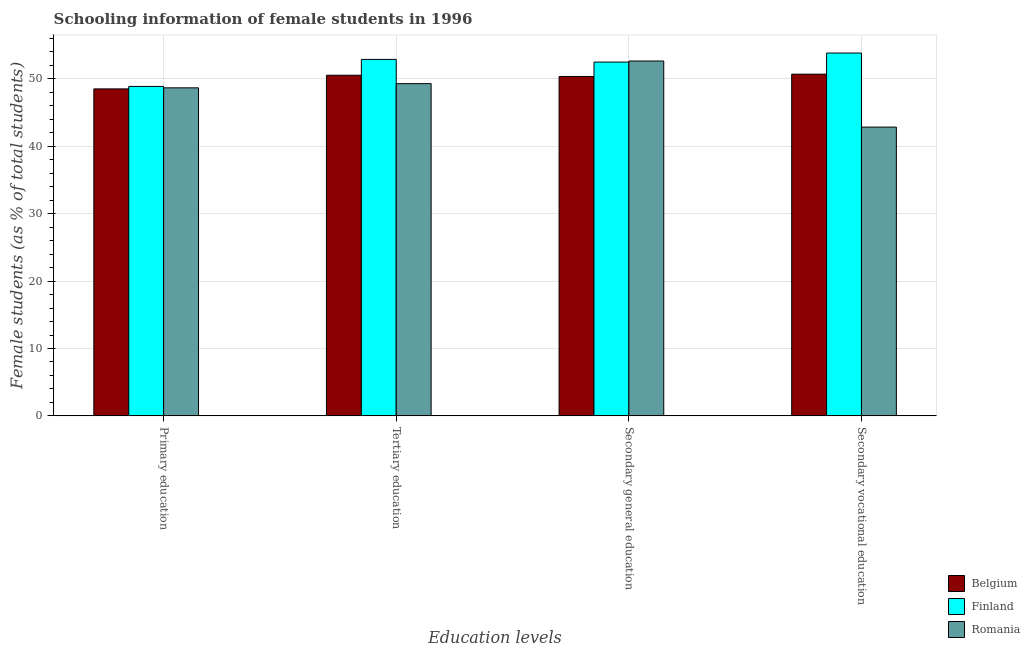How many different coloured bars are there?
Make the answer very short. 3. How many groups of bars are there?
Provide a short and direct response. 4. Are the number of bars on each tick of the X-axis equal?
Ensure brevity in your answer.  Yes. How many bars are there on the 4th tick from the left?
Your answer should be compact. 3. What is the label of the 2nd group of bars from the left?
Provide a succinct answer. Tertiary education. What is the percentage of female students in primary education in Belgium?
Offer a very short reply. 48.52. Across all countries, what is the maximum percentage of female students in secondary education?
Your response must be concise. 52.66. Across all countries, what is the minimum percentage of female students in tertiary education?
Ensure brevity in your answer.  49.3. In which country was the percentage of female students in secondary vocational education minimum?
Provide a succinct answer. Romania. What is the total percentage of female students in primary education in the graph?
Keep it short and to the point. 146.09. What is the difference between the percentage of female students in tertiary education in Finland and that in Romania?
Ensure brevity in your answer.  3.6. What is the difference between the percentage of female students in primary education in Finland and the percentage of female students in tertiary education in Belgium?
Provide a succinct answer. -1.66. What is the average percentage of female students in tertiary education per country?
Provide a succinct answer. 50.92. What is the difference between the percentage of female students in primary education and percentage of female students in tertiary education in Romania?
Your response must be concise. -0.62. What is the ratio of the percentage of female students in secondary education in Belgium to that in Romania?
Your answer should be compact. 0.96. Is the difference between the percentage of female students in tertiary education in Belgium and Finland greater than the difference between the percentage of female students in secondary vocational education in Belgium and Finland?
Your answer should be compact. Yes. What is the difference between the highest and the second highest percentage of female students in secondary vocational education?
Keep it short and to the point. 3.14. What is the difference between the highest and the lowest percentage of female students in secondary education?
Your answer should be very brief. 2.29. What does the 3rd bar from the left in Secondary vocational education represents?
Offer a very short reply. Romania. What does the 1st bar from the right in Secondary vocational education represents?
Provide a succinct answer. Romania. Is it the case that in every country, the sum of the percentage of female students in primary education and percentage of female students in tertiary education is greater than the percentage of female students in secondary education?
Give a very brief answer. Yes. How many bars are there?
Provide a short and direct response. 12. Are all the bars in the graph horizontal?
Make the answer very short. No. Are the values on the major ticks of Y-axis written in scientific E-notation?
Your answer should be very brief. No. Does the graph contain grids?
Your answer should be very brief. Yes. What is the title of the graph?
Give a very brief answer. Schooling information of female students in 1996. Does "Middle East & North Africa (all income levels)" appear as one of the legend labels in the graph?
Provide a succinct answer. No. What is the label or title of the X-axis?
Your answer should be very brief. Education levels. What is the label or title of the Y-axis?
Make the answer very short. Female students (as % of total students). What is the Female students (as % of total students) in Belgium in Primary education?
Provide a succinct answer. 48.52. What is the Female students (as % of total students) of Finland in Primary education?
Provide a succinct answer. 48.89. What is the Female students (as % of total students) in Romania in Primary education?
Give a very brief answer. 48.68. What is the Female students (as % of total students) of Belgium in Tertiary education?
Provide a succinct answer. 50.55. What is the Female students (as % of total students) in Finland in Tertiary education?
Ensure brevity in your answer.  52.9. What is the Female students (as % of total students) in Romania in Tertiary education?
Ensure brevity in your answer.  49.3. What is the Female students (as % of total students) of Belgium in Secondary general education?
Provide a succinct answer. 50.37. What is the Female students (as % of total students) of Finland in Secondary general education?
Ensure brevity in your answer.  52.5. What is the Female students (as % of total students) of Romania in Secondary general education?
Make the answer very short. 52.66. What is the Female students (as % of total students) in Belgium in Secondary vocational education?
Give a very brief answer. 50.71. What is the Female students (as % of total students) of Finland in Secondary vocational education?
Your answer should be compact. 53.85. What is the Female students (as % of total students) in Romania in Secondary vocational education?
Provide a succinct answer. 42.85. Across all Education levels, what is the maximum Female students (as % of total students) of Belgium?
Offer a terse response. 50.71. Across all Education levels, what is the maximum Female students (as % of total students) in Finland?
Offer a very short reply. 53.85. Across all Education levels, what is the maximum Female students (as % of total students) in Romania?
Your answer should be compact. 52.66. Across all Education levels, what is the minimum Female students (as % of total students) of Belgium?
Your answer should be very brief. 48.52. Across all Education levels, what is the minimum Female students (as % of total students) of Finland?
Your answer should be compact. 48.89. Across all Education levels, what is the minimum Female students (as % of total students) in Romania?
Your response must be concise. 42.85. What is the total Female students (as % of total students) of Belgium in the graph?
Your response must be concise. 200.15. What is the total Female students (as % of total students) of Finland in the graph?
Give a very brief answer. 208.14. What is the total Female students (as % of total students) in Romania in the graph?
Your answer should be very brief. 193.49. What is the difference between the Female students (as % of total students) of Belgium in Primary education and that in Tertiary education?
Offer a very short reply. -2.03. What is the difference between the Female students (as % of total students) in Finland in Primary education and that in Tertiary education?
Make the answer very short. -4.01. What is the difference between the Female students (as % of total students) in Romania in Primary education and that in Tertiary education?
Offer a very short reply. -0.62. What is the difference between the Female students (as % of total students) of Belgium in Primary education and that in Secondary general education?
Give a very brief answer. -1.84. What is the difference between the Female students (as % of total students) in Finland in Primary education and that in Secondary general education?
Offer a very short reply. -3.61. What is the difference between the Female students (as % of total students) in Romania in Primary education and that in Secondary general education?
Offer a very short reply. -3.98. What is the difference between the Female students (as % of total students) of Belgium in Primary education and that in Secondary vocational education?
Make the answer very short. -2.19. What is the difference between the Female students (as % of total students) in Finland in Primary education and that in Secondary vocational education?
Give a very brief answer. -4.96. What is the difference between the Female students (as % of total students) in Romania in Primary education and that in Secondary vocational education?
Provide a succinct answer. 5.83. What is the difference between the Female students (as % of total students) in Belgium in Tertiary education and that in Secondary general education?
Offer a very short reply. 0.18. What is the difference between the Female students (as % of total students) in Finland in Tertiary education and that in Secondary general education?
Your response must be concise. 0.39. What is the difference between the Female students (as % of total students) of Romania in Tertiary education and that in Secondary general education?
Your answer should be very brief. -3.36. What is the difference between the Female students (as % of total students) in Belgium in Tertiary education and that in Secondary vocational education?
Ensure brevity in your answer.  -0.16. What is the difference between the Female students (as % of total students) of Finland in Tertiary education and that in Secondary vocational education?
Keep it short and to the point. -0.95. What is the difference between the Female students (as % of total students) of Romania in Tertiary education and that in Secondary vocational education?
Make the answer very short. 6.45. What is the difference between the Female students (as % of total students) of Belgium in Secondary general education and that in Secondary vocational education?
Provide a succinct answer. -0.34. What is the difference between the Female students (as % of total students) of Finland in Secondary general education and that in Secondary vocational education?
Provide a short and direct response. -1.34. What is the difference between the Female students (as % of total students) of Romania in Secondary general education and that in Secondary vocational education?
Make the answer very short. 9.81. What is the difference between the Female students (as % of total students) of Belgium in Primary education and the Female students (as % of total students) of Finland in Tertiary education?
Keep it short and to the point. -4.37. What is the difference between the Female students (as % of total students) in Belgium in Primary education and the Female students (as % of total students) in Romania in Tertiary education?
Give a very brief answer. -0.78. What is the difference between the Female students (as % of total students) of Finland in Primary education and the Female students (as % of total students) of Romania in Tertiary education?
Provide a short and direct response. -0.41. What is the difference between the Female students (as % of total students) in Belgium in Primary education and the Female students (as % of total students) in Finland in Secondary general education?
Offer a terse response. -3.98. What is the difference between the Female students (as % of total students) in Belgium in Primary education and the Female students (as % of total students) in Romania in Secondary general education?
Provide a succinct answer. -4.14. What is the difference between the Female students (as % of total students) in Finland in Primary education and the Female students (as % of total students) in Romania in Secondary general education?
Your answer should be compact. -3.77. What is the difference between the Female students (as % of total students) of Belgium in Primary education and the Female students (as % of total students) of Finland in Secondary vocational education?
Your answer should be very brief. -5.32. What is the difference between the Female students (as % of total students) of Belgium in Primary education and the Female students (as % of total students) of Romania in Secondary vocational education?
Keep it short and to the point. 5.67. What is the difference between the Female students (as % of total students) of Finland in Primary education and the Female students (as % of total students) of Romania in Secondary vocational education?
Your answer should be compact. 6.04. What is the difference between the Female students (as % of total students) in Belgium in Tertiary education and the Female students (as % of total students) in Finland in Secondary general education?
Offer a terse response. -1.95. What is the difference between the Female students (as % of total students) of Belgium in Tertiary education and the Female students (as % of total students) of Romania in Secondary general education?
Make the answer very short. -2.11. What is the difference between the Female students (as % of total students) of Finland in Tertiary education and the Female students (as % of total students) of Romania in Secondary general education?
Your response must be concise. 0.24. What is the difference between the Female students (as % of total students) of Belgium in Tertiary education and the Female students (as % of total students) of Finland in Secondary vocational education?
Offer a terse response. -3.3. What is the difference between the Female students (as % of total students) in Belgium in Tertiary education and the Female students (as % of total students) in Romania in Secondary vocational education?
Your answer should be compact. 7.7. What is the difference between the Female students (as % of total students) in Finland in Tertiary education and the Female students (as % of total students) in Romania in Secondary vocational education?
Ensure brevity in your answer.  10.04. What is the difference between the Female students (as % of total students) of Belgium in Secondary general education and the Female students (as % of total students) of Finland in Secondary vocational education?
Offer a terse response. -3.48. What is the difference between the Female students (as % of total students) of Belgium in Secondary general education and the Female students (as % of total students) of Romania in Secondary vocational education?
Your answer should be compact. 7.51. What is the difference between the Female students (as % of total students) in Finland in Secondary general education and the Female students (as % of total students) in Romania in Secondary vocational education?
Offer a very short reply. 9.65. What is the average Female students (as % of total students) of Belgium per Education levels?
Your answer should be very brief. 50.04. What is the average Female students (as % of total students) in Finland per Education levels?
Make the answer very short. 52.03. What is the average Female students (as % of total students) in Romania per Education levels?
Offer a very short reply. 48.37. What is the difference between the Female students (as % of total students) in Belgium and Female students (as % of total students) in Finland in Primary education?
Provide a succinct answer. -0.37. What is the difference between the Female students (as % of total students) of Belgium and Female students (as % of total students) of Romania in Primary education?
Provide a short and direct response. -0.16. What is the difference between the Female students (as % of total students) in Finland and Female students (as % of total students) in Romania in Primary education?
Your response must be concise. 0.21. What is the difference between the Female students (as % of total students) in Belgium and Female students (as % of total students) in Finland in Tertiary education?
Offer a very short reply. -2.35. What is the difference between the Female students (as % of total students) of Belgium and Female students (as % of total students) of Romania in Tertiary education?
Offer a very short reply. 1.25. What is the difference between the Female students (as % of total students) in Finland and Female students (as % of total students) in Romania in Tertiary education?
Offer a terse response. 3.6. What is the difference between the Female students (as % of total students) of Belgium and Female students (as % of total students) of Finland in Secondary general education?
Provide a succinct answer. -2.14. What is the difference between the Female students (as % of total students) in Belgium and Female students (as % of total students) in Romania in Secondary general education?
Give a very brief answer. -2.29. What is the difference between the Female students (as % of total students) in Finland and Female students (as % of total students) in Romania in Secondary general education?
Provide a succinct answer. -0.16. What is the difference between the Female students (as % of total students) of Belgium and Female students (as % of total students) of Finland in Secondary vocational education?
Provide a short and direct response. -3.14. What is the difference between the Female students (as % of total students) in Belgium and Female students (as % of total students) in Romania in Secondary vocational education?
Give a very brief answer. 7.86. What is the difference between the Female students (as % of total students) in Finland and Female students (as % of total students) in Romania in Secondary vocational education?
Ensure brevity in your answer.  10.99. What is the ratio of the Female students (as % of total students) of Belgium in Primary education to that in Tertiary education?
Provide a short and direct response. 0.96. What is the ratio of the Female students (as % of total students) of Finland in Primary education to that in Tertiary education?
Your answer should be compact. 0.92. What is the ratio of the Female students (as % of total students) in Romania in Primary education to that in Tertiary education?
Your answer should be very brief. 0.99. What is the ratio of the Female students (as % of total students) of Belgium in Primary education to that in Secondary general education?
Your answer should be very brief. 0.96. What is the ratio of the Female students (as % of total students) of Finland in Primary education to that in Secondary general education?
Make the answer very short. 0.93. What is the ratio of the Female students (as % of total students) of Romania in Primary education to that in Secondary general education?
Provide a short and direct response. 0.92. What is the ratio of the Female students (as % of total students) in Belgium in Primary education to that in Secondary vocational education?
Your response must be concise. 0.96. What is the ratio of the Female students (as % of total students) in Finland in Primary education to that in Secondary vocational education?
Keep it short and to the point. 0.91. What is the ratio of the Female students (as % of total students) of Romania in Primary education to that in Secondary vocational education?
Provide a succinct answer. 1.14. What is the ratio of the Female students (as % of total students) of Belgium in Tertiary education to that in Secondary general education?
Ensure brevity in your answer.  1. What is the ratio of the Female students (as % of total students) of Finland in Tertiary education to that in Secondary general education?
Ensure brevity in your answer.  1.01. What is the ratio of the Female students (as % of total students) of Romania in Tertiary education to that in Secondary general education?
Make the answer very short. 0.94. What is the ratio of the Female students (as % of total students) of Finland in Tertiary education to that in Secondary vocational education?
Provide a succinct answer. 0.98. What is the ratio of the Female students (as % of total students) in Romania in Tertiary education to that in Secondary vocational education?
Offer a very short reply. 1.15. What is the ratio of the Female students (as % of total students) in Belgium in Secondary general education to that in Secondary vocational education?
Provide a succinct answer. 0.99. What is the ratio of the Female students (as % of total students) in Finland in Secondary general education to that in Secondary vocational education?
Provide a succinct answer. 0.97. What is the ratio of the Female students (as % of total students) of Romania in Secondary general education to that in Secondary vocational education?
Keep it short and to the point. 1.23. What is the difference between the highest and the second highest Female students (as % of total students) of Belgium?
Provide a succinct answer. 0.16. What is the difference between the highest and the second highest Female students (as % of total students) of Finland?
Your response must be concise. 0.95. What is the difference between the highest and the second highest Female students (as % of total students) of Romania?
Your answer should be very brief. 3.36. What is the difference between the highest and the lowest Female students (as % of total students) of Belgium?
Make the answer very short. 2.19. What is the difference between the highest and the lowest Female students (as % of total students) in Finland?
Your answer should be very brief. 4.96. What is the difference between the highest and the lowest Female students (as % of total students) in Romania?
Provide a short and direct response. 9.81. 